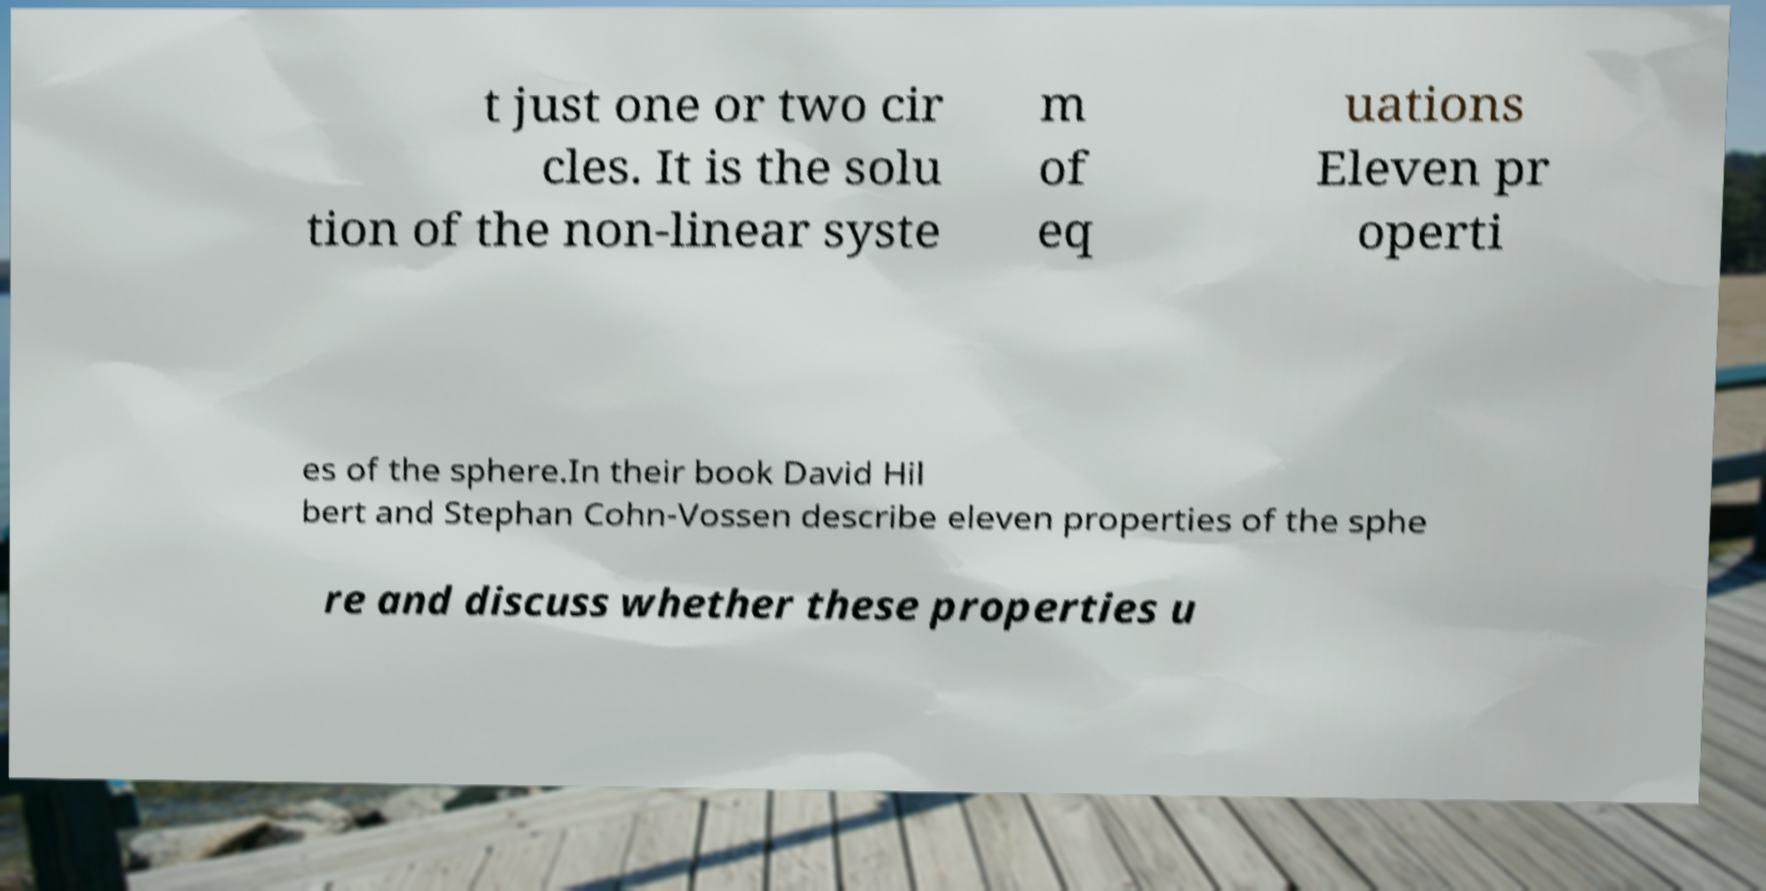Can you accurately transcribe the text from the provided image for me? t just one or two cir cles. It is the solu tion of the non-linear syste m of eq uations Eleven pr operti es of the sphere.In their book David Hil bert and Stephan Cohn-Vossen describe eleven properties of the sphe re and discuss whether these properties u 